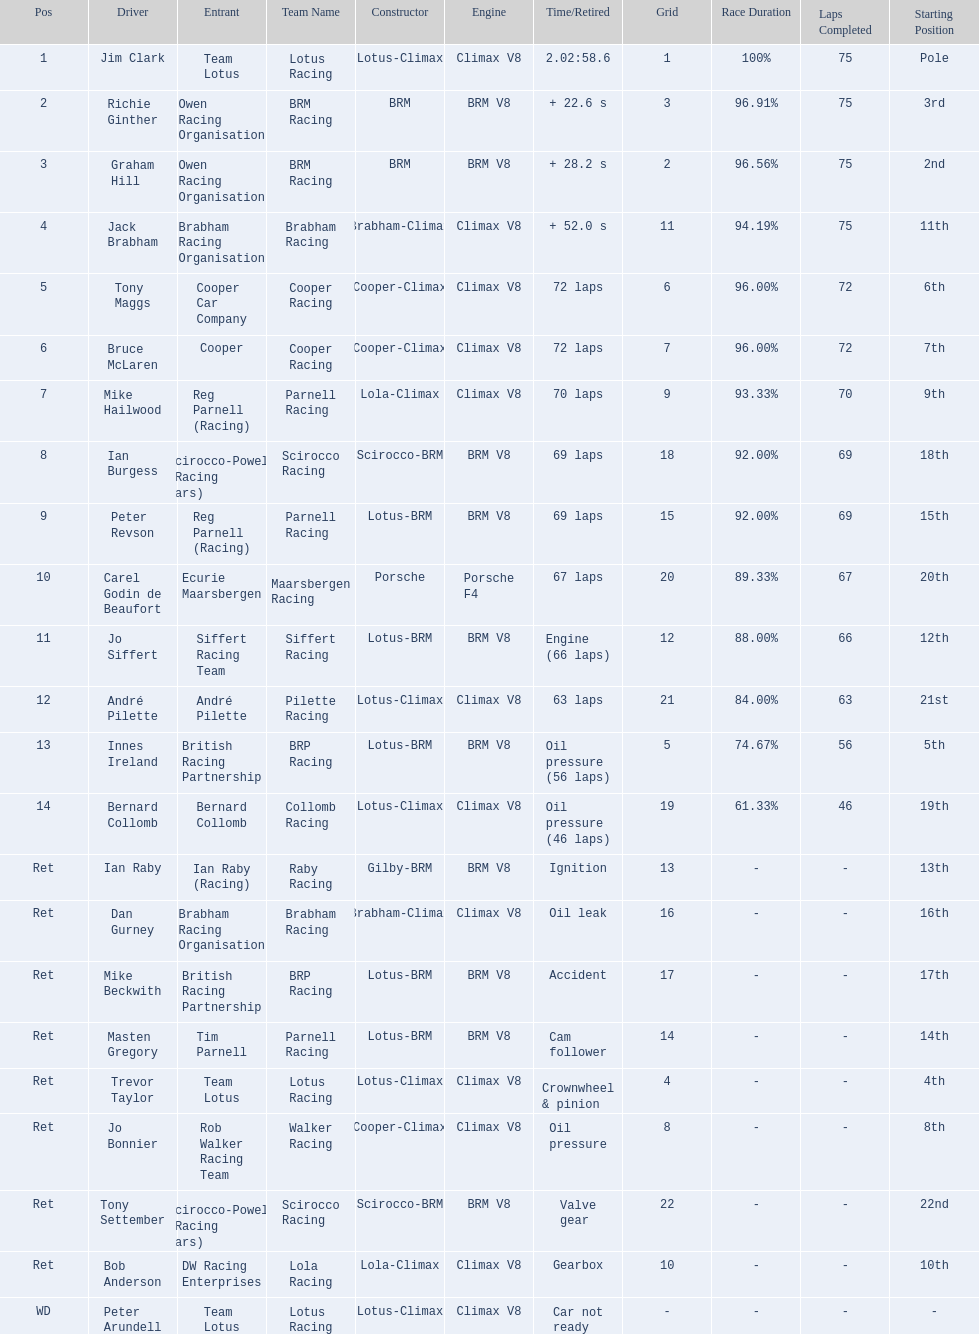Who are all the drivers? Jim Clark, Richie Ginther, Graham Hill, Jack Brabham, Tony Maggs, Bruce McLaren, Mike Hailwood, Ian Burgess, Peter Revson, Carel Godin de Beaufort, Jo Siffert, André Pilette, Innes Ireland, Bernard Collomb, Ian Raby, Dan Gurney, Mike Beckwith, Masten Gregory, Trevor Taylor, Jo Bonnier, Tony Settember, Bob Anderson, Peter Arundell. Which drove a cooper-climax? Tony Maggs, Bruce McLaren, Jo Bonnier. Of those, who was the top finisher? Tony Maggs. 